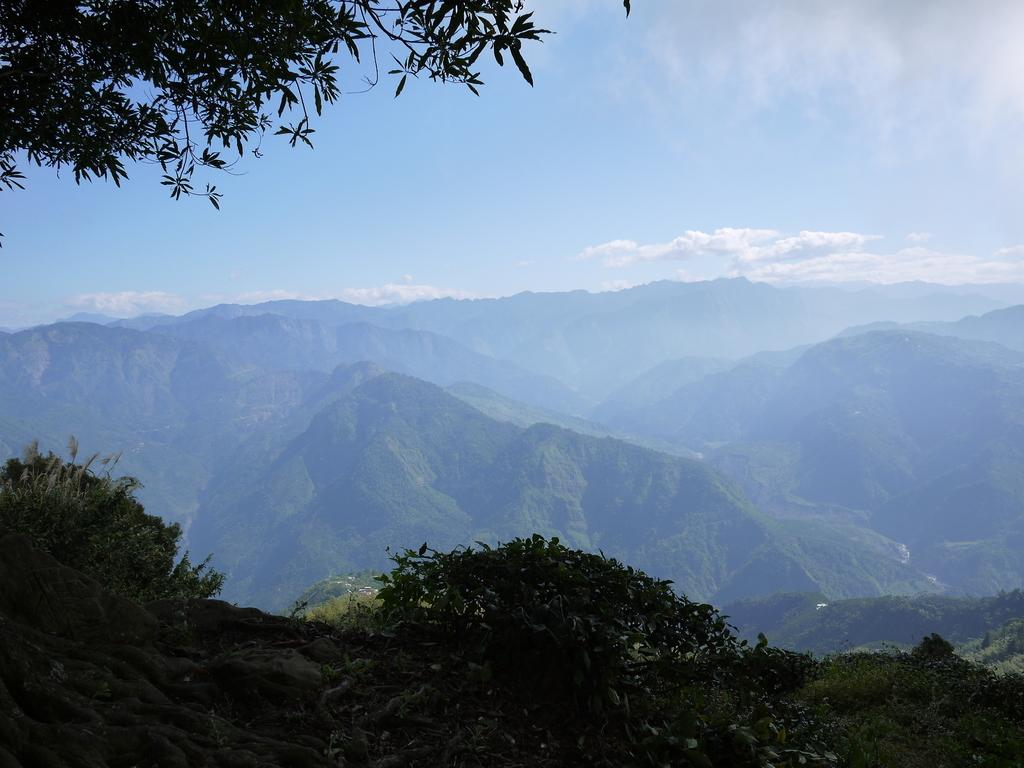What type of vegetation can be seen in the image? There are leaves and plants in the image. What is visible in the background of the image? There are mountains and the sky visible in the background of the image. What type of brick is used to build the mountains in the image? There are no bricks present in the image, as the mountains are natural formations. What seeds can be seen growing into plants in the image? There are no seeds visible in the image; only mature plants are present. 